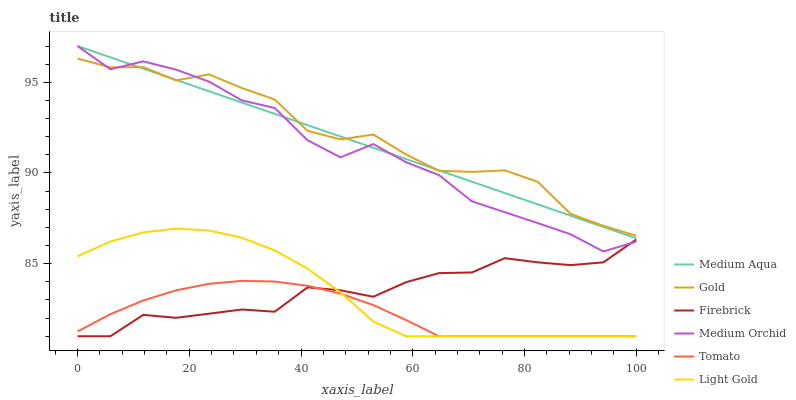Does Tomato have the minimum area under the curve?
Answer yes or no. Yes. Does Gold have the maximum area under the curve?
Answer yes or no. Yes. Does Firebrick have the minimum area under the curve?
Answer yes or no. No. Does Firebrick have the maximum area under the curve?
Answer yes or no. No. Is Medium Aqua the smoothest?
Answer yes or no. Yes. Is Medium Orchid the roughest?
Answer yes or no. Yes. Is Gold the smoothest?
Answer yes or no. No. Is Gold the roughest?
Answer yes or no. No. Does Tomato have the lowest value?
Answer yes or no. Yes. Does Gold have the lowest value?
Answer yes or no. No. Does Medium Aqua have the highest value?
Answer yes or no. Yes. Does Gold have the highest value?
Answer yes or no. No. Is Firebrick less than Medium Aqua?
Answer yes or no. Yes. Is Medium Aqua greater than Firebrick?
Answer yes or no. Yes. Does Firebrick intersect Light Gold?
Answer yes or no. Yes. Is Firebrick less than Light Gold?
Answer yes or no. No. Is Firebrick greater than Light Gold?
Answer yes or no. No. Does Firebrick intersect Medium Aqua?
Answer yes or no. No. 